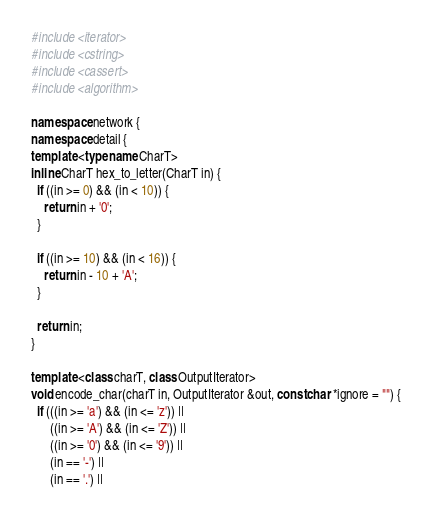<code> <loc_0><loc_0><loc_500><loc_500><_C++_>#include <iterator>
#include <cstring>
#include <cassert>
#include <algorithm>

namespace network {
namespace detail {
template <typename CharT>
inline CharT hex_to_letter(CharT in) {
  if ((in >= 0) && (in < 10)) {
    return in + '0';
  }

  if ((in >= 10) && (in < 16)) {
    return in - 10 + 'A';
  }

  return in;
}

template <class charT, class OutputIterator>
void encode_char(charT in, OutputIterator &out, const char *ignore = "") {
  if (((in >= 'a') && (in <= 'z')) ||
      ((in >= 'A') && (in <= 'Z')) ||
      ((in >= '0') && (in <= '9')) ||
      (in == '-') ||
      (in == '.') ||</code> 